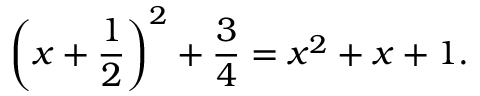Convert formula to latex. <formula><loc_0><loc_0><loc_500><loc_500>\left ( x + { \frac { 1 } { 2 } } \right ) ^ { 2 } + { \frac { 3 } { 4 } } = x ^ { 2 } + x + 1 .</formula> 